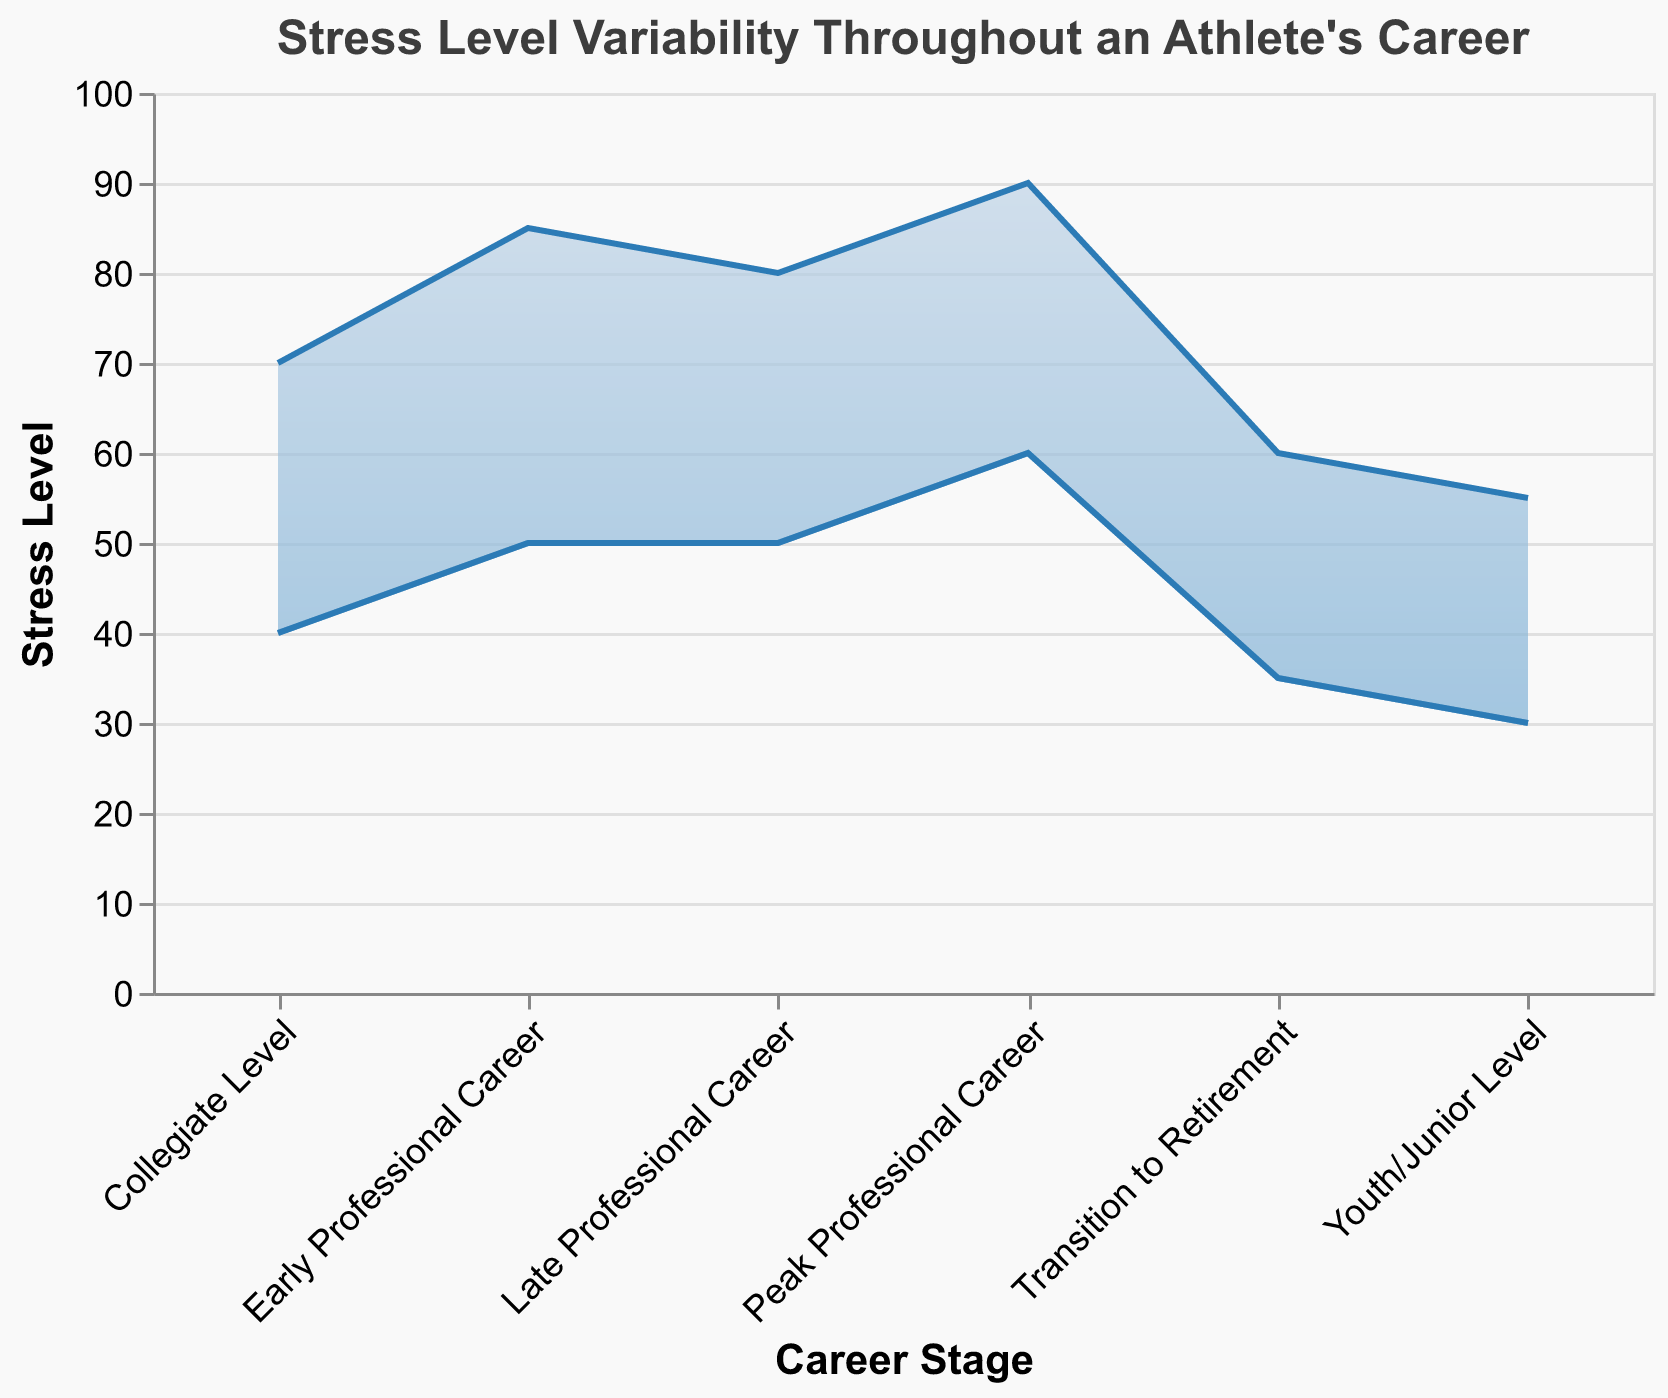What is the title of the chart? The title of the chart is displayed at the top and reads "Stress Level Variability Throughout an Athlete's Career."
Answer: Stress Level Variability Throughout an Athlete's Career What are the minimum and maximum stress levels for the Early Professional Career stage? Look at the area representing the Early Professional Career stage. The lower boundary (Minimum Stress Level) is 50, and the upper boundary (Maximum Stress Level) is 85.
Answer: Minimum 50, Maximum 85 Which career stage shows the highest range of stress levels? Calculate the range (Maximum Stress Level - Minimum Stress Level) for each stage and compare them. The range for the Peak Professional Career is the highest (90 - 60 = 30).
Answer: Peak Professional Career How does the stress level range change from the Collegiate Level to Early Professional Career? For the Collegiate Level, the range is 70 - 40 = 30. For the Early Professional Career, the range is 85 - 50 = 35. The range increases by 35 - 30 = 5.
Answer: Increases by 5 What is the difference between the minimum stress levels at the Peak Professional Career and the Transition to Retirement stages? The minimum stress level for Peak Professional Career is 60, and for Transition to Retirement, it is 35. The difference is 60 - 35 = 25.
Answer: 25 During which stage does the minimum stress level reach its highest value? Check the Minimum Stress Level for each stage: the Peak Professional Career stage has the highest minimum stress level at 60.
Answer: Peak Professional Career What is the average of the minimum stress levels across all career stages? Calculate the average: (30 + 40 + 50 + 60 + 50 + 35) / 6 = 265 / 6 ≈ 44.17.
Answer: 44.17 Does the stress level decrease in the Late Professional Career stage compared to the Peak Professional Career stage? Compare both the minimum and maximum stress levels: In the Peak Professional Career, the levels are 60 to 90. In the Late Professional Career, they are 50 to 80. Both minimum and maximum stress levels decrease.
Answer: Yes What is the trend in maximum stress levels from the Youth/Junior Level to the Peak Professional Career stage? List the maximum stress levels in order: 55, 70, 85, and 90. The trend shows an increasing pattern.
Answer: Increasing pattern At which stage is the minimum stress level the lowest? Check the minimum stress levels for all stages; Youth/Junior Level has the lowest at 30.
Answer: Youth/Junior Level 